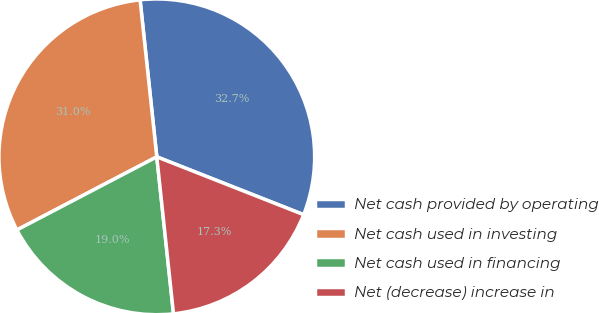<chart> <loc_0><loc_0><loc_500><loc_500><pie_chart><fcel>Net cash provided by operating<fcel>Net cash used in investing<fcel>Net cash used in financing<fcel>Net (decrease) increase in<nl><fcel>32.66%<fcel>30.98%<fcel>19.02%<fcel>17.34%<nl></chart> 